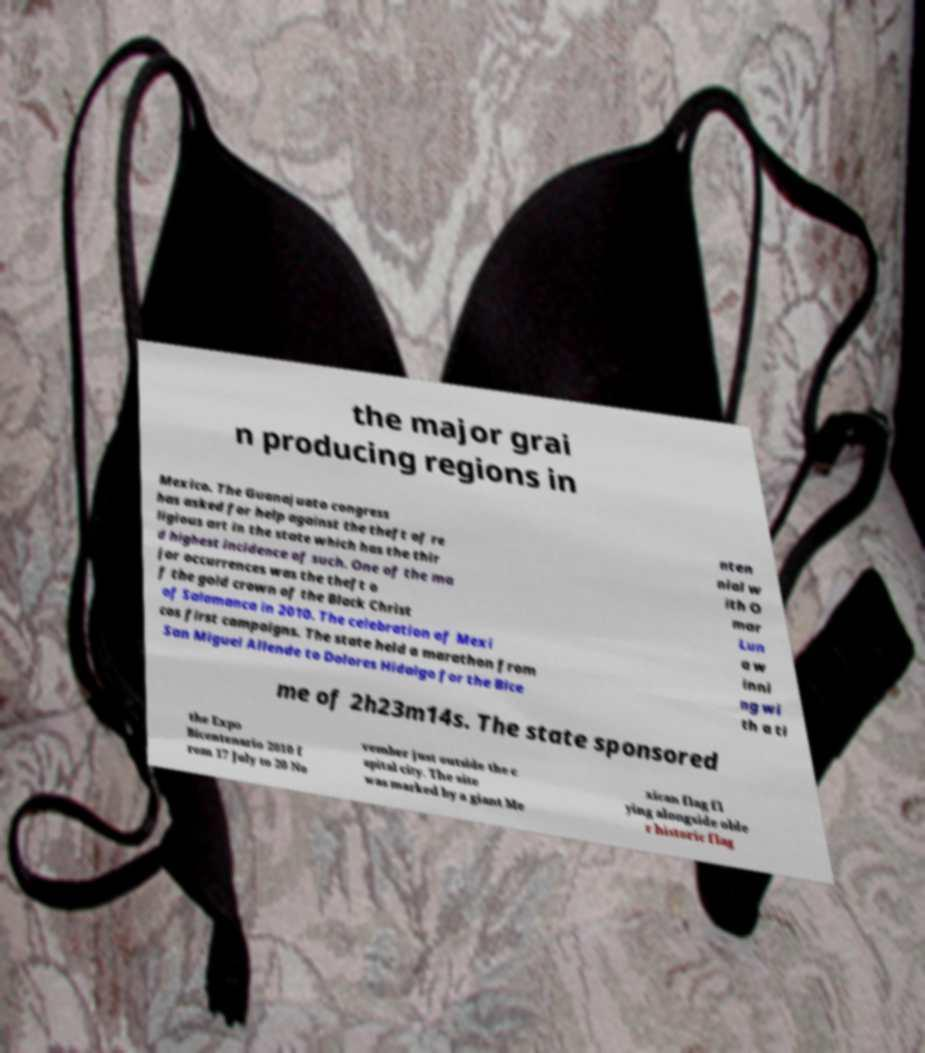What messages or text are displayed in this image? I need them in a readable, typed format. the major grai n producing regions in Mexico. The Guanajuato congress has asked for help against the theft of re ligious art in the state which has the thir d highest incidence of such. One of the ma jor occurrences was the theft o f the gold crown of the Black Christ of Salamanca in 2010. The celebration of Mexi cos first campaigns. The state held a marathon from San Miguel Allende to Dolores Hidalgo for the Bice nten nial w ith O mar Lun a w inni ng wi th a ti me of 2h23m14s. The state sponsored the Expo Bicentenario 2010 f rom 17 July to 20 No vember just outside the c apital city. The site was marked by a giant Me xican flag fl ying alongside olde r historic flag 